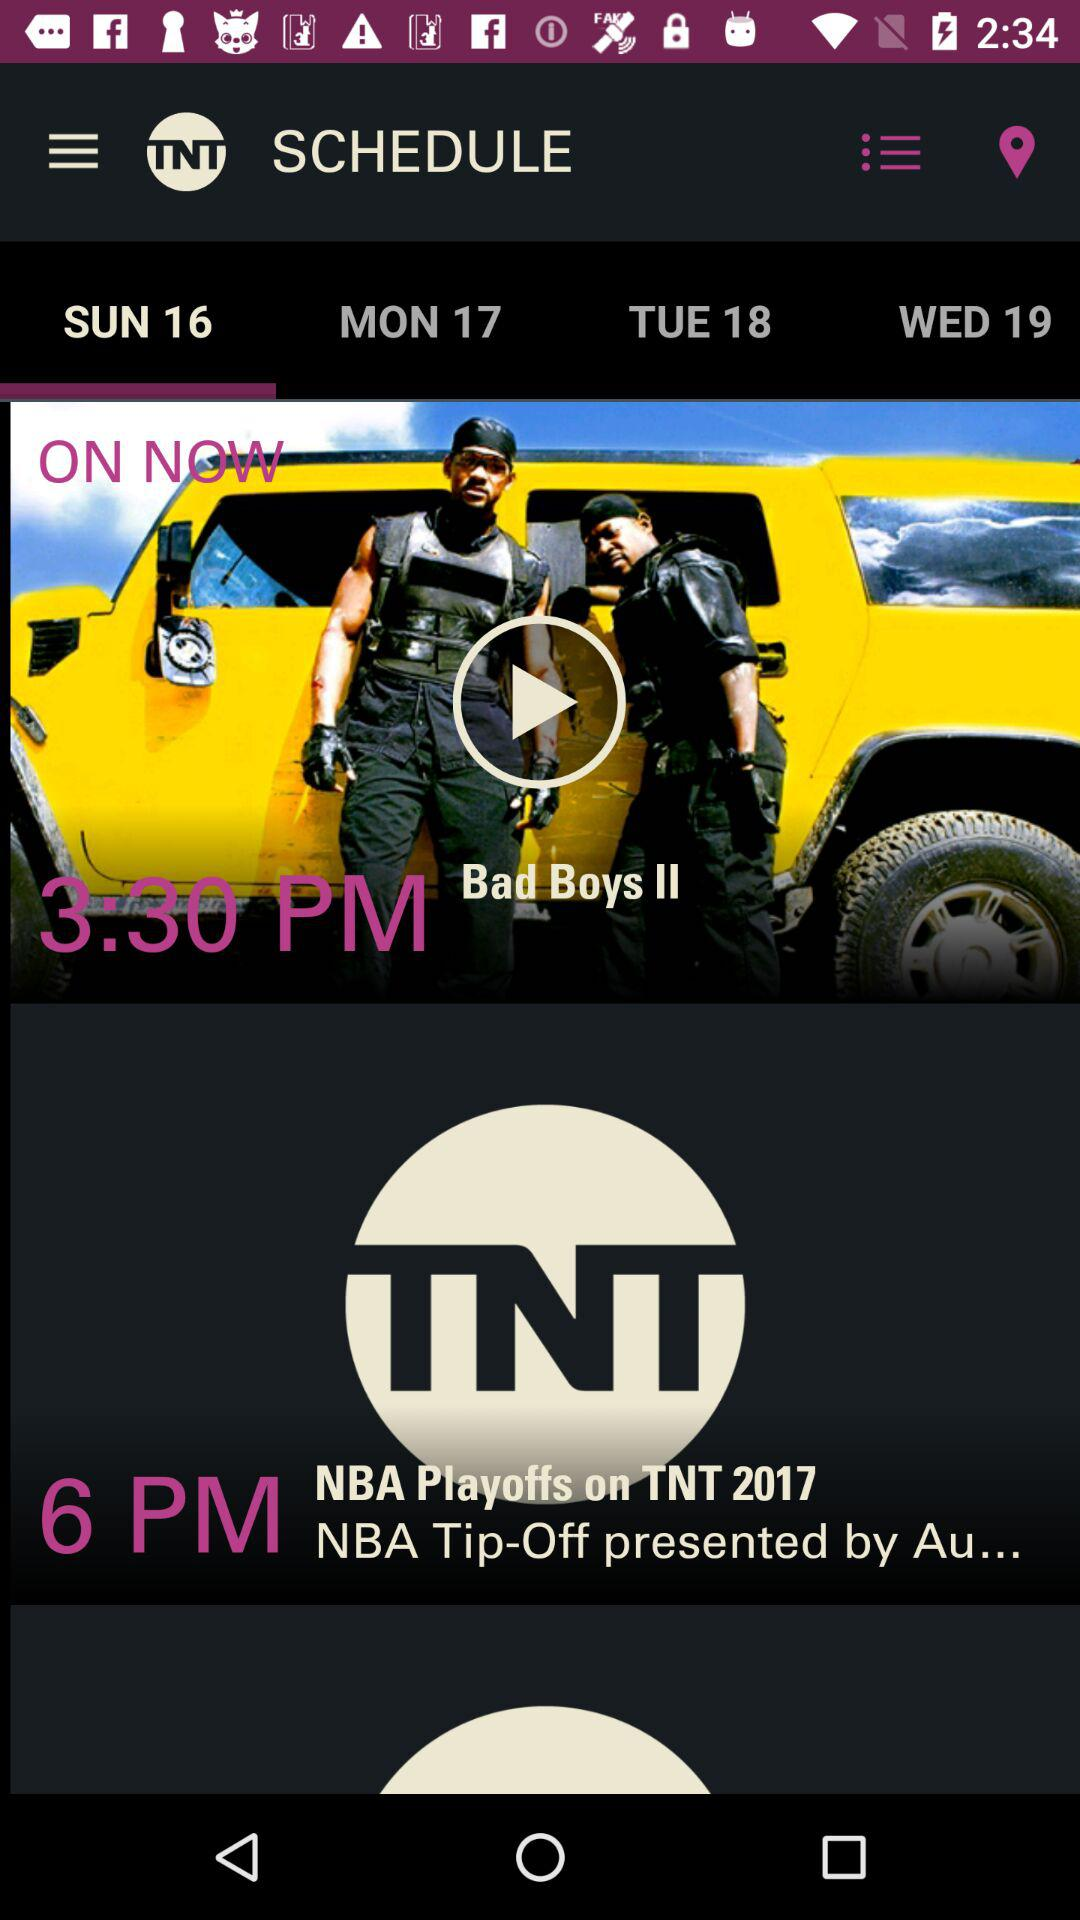What is the application name? The application name is "Watch TNT". 